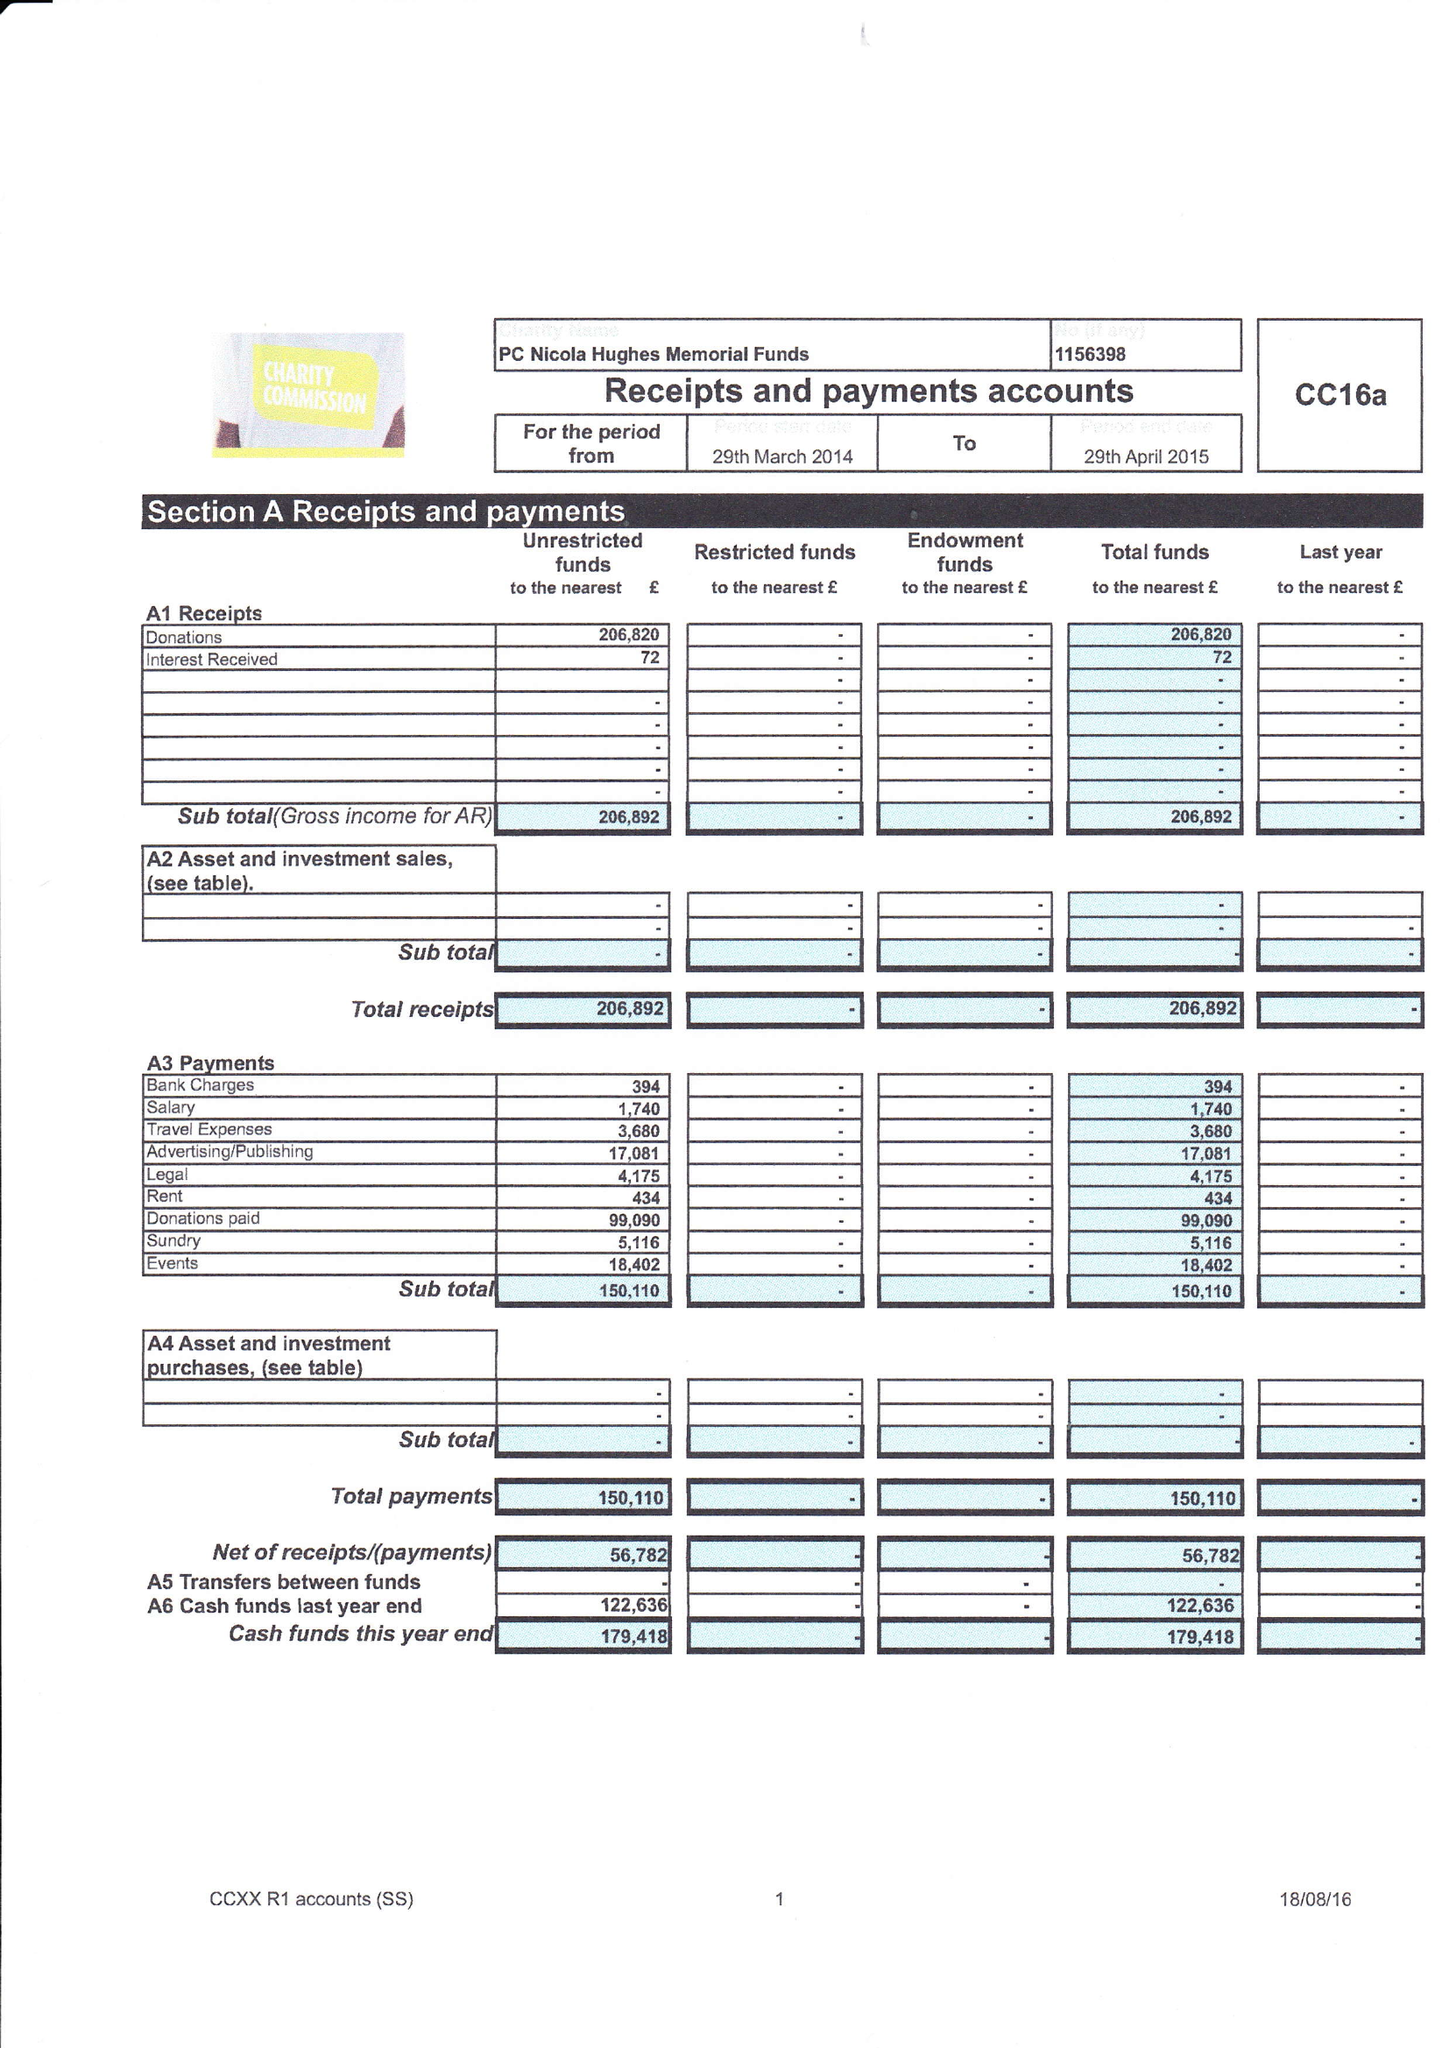What is the value for the spending_annually_in_british_pounds?
Answer the question using a single word or phrase. 150110.00 